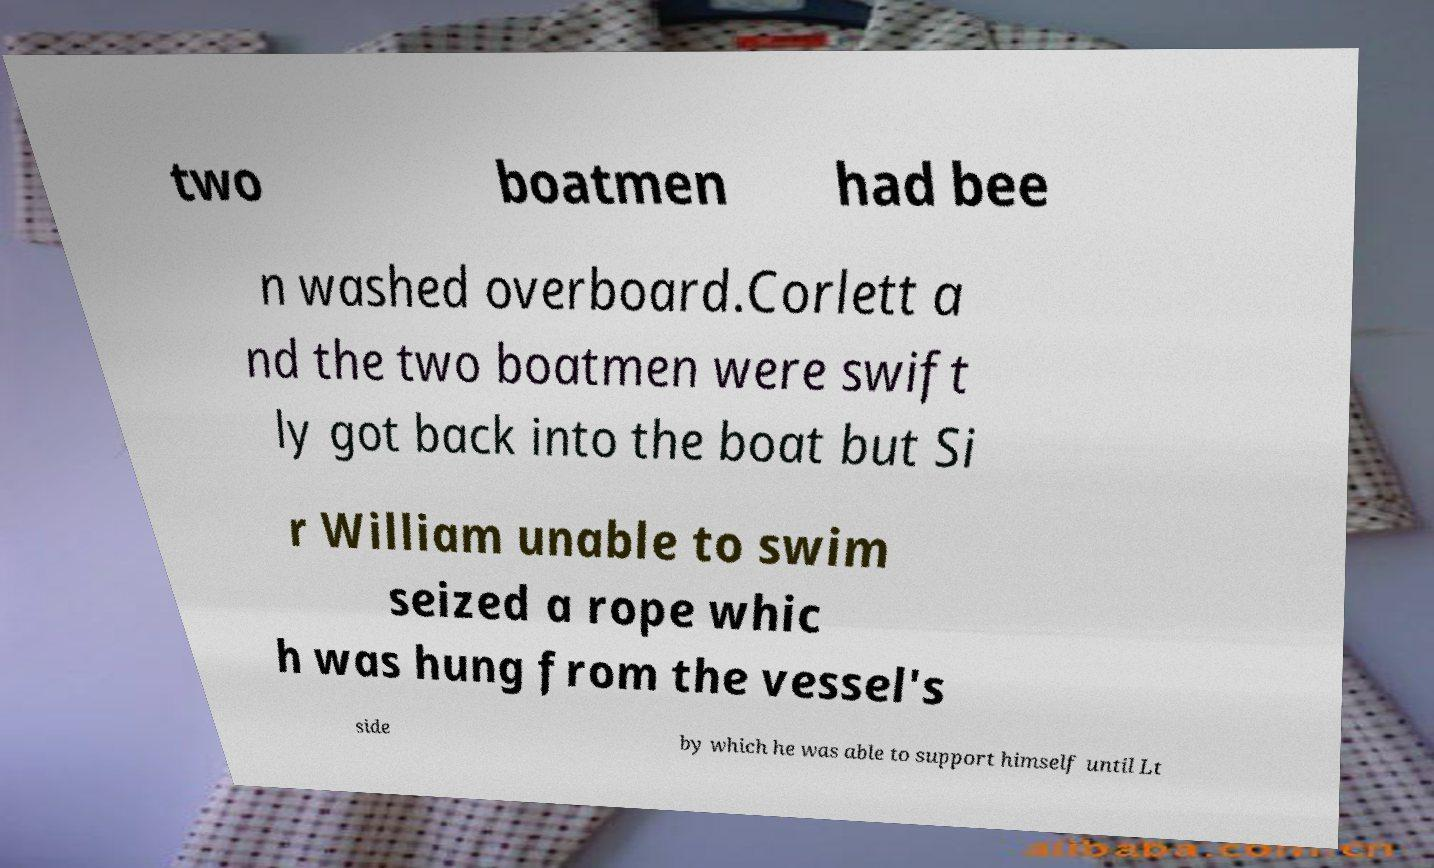I need the written content from this picture converted into text. Can you do that? two boatmen had bee n washed overboard.Corlett a nd the two boatmen were swift ly got back into the boat but Si r William unable to swim seized a rope whic h was hung from the vessel's side by which he was able to support himself until Lt 